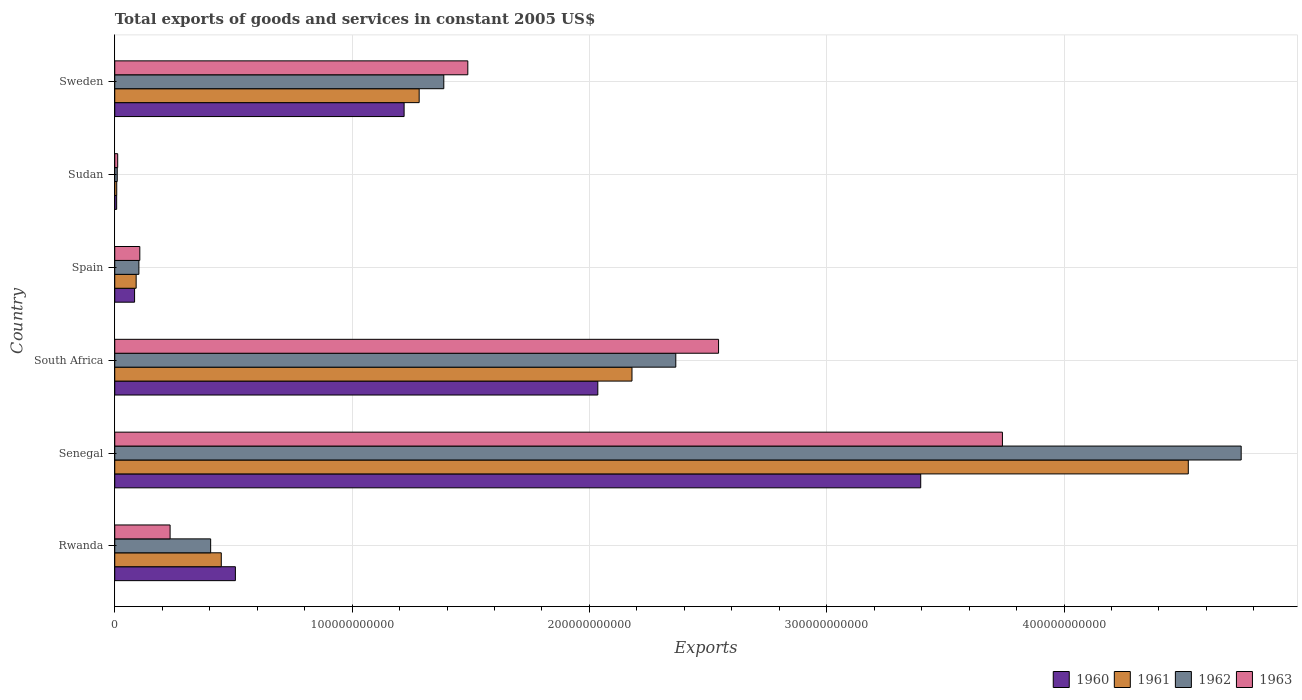How many different coloured bars are there?
Your answer should be very brief. 4. Are the number of bars per tick equal to the number of legend labels?
Your response must be concise. Yes. Are the number of bars on each tick of the Y-axis equal?
Offer a terse response. Yes. What is the label of the 4th group of bars from the top?
Offer a terse response. South Africa. In how many cases, is the number of bars for a given country not equal to the number of legend labels?
Ensure brevity in your answer.  0. What is the total exports of goods and services in 1962 in Spain?
Offer a very short reply. 1.02e+1. Across all countries, what is the maximum total exports of goods and services in 1963?
Your answer should be compact. 3.74e+11. Across all countries, what is the minimum total exports of goods and services in 1960?
Keep it short and to the point. 8.03e+08. In which country was the total exports of goods and services in 1962 maximum?
Your answer should be compact. Senegal. In which country was the total exports of goods and services in 1961 minimum?
Your answer should be compact. Sudan. What is the total total exports of goods and services in 1963 in the graph?
Keep it short and to the point. 8.12e+11. What is the difference between the total exports of goods and services in 1960 in Senegal and that in Spain?
Give a very brief answer. 3.31e+11. What is the difference between the total exports of goods and services in 1963 in Sweden and the total exports of goods and services in 1962 in Spain?
Your response must be concise. 1.39e+11. What is the average total exports of goods and services in 1962 per country?
Keep it short and to the point. 1.50e+11. What is the difference between the total exports of goods and services in 1962 and total exports of goods and services in 1960 in South Africa?
Offer a very short reply. 3.29e+1. What is the ratio of the total exports of goods and services in 1962 in Senegal to that in South Africa?
Provide a succinct answer. 2.01. Is the difference between the total exports of goods and services in 1962 in Rwanda and Sudan greater than the difference between the total exports of goods and services in 1960 in Rwanda and Sudan?
Your answer should be very brief. No. What is the difference between the highest and the second highest total exports of goods and services in 1963?
Offer a very short reply. 1.20e+11. What is the difference between the highest and the lowest total exports of goods and services in 1960?
Keep it short and to the point. 3.39e+11. Is the sum of the total exports of goods and services in 1961 in South Africa and Sweden greater than the maximum total exports of goods and services in 1960 across all countries?
Keep it short and to the point. Yes. What does the 3rd bar from the top in South Africa represents?
Keep it short and to the point. 1961. Is it the case that in every country, the sum of the total exports of goods and services in 1960 and total exports of goods and services in 1962 is greater than the total exports of goods and services in 1963?
Ensure brevity in your answer.  Yes. How many bars are there?
Offer a very short reply. 24. Are all the bars in the graph horizontal?
Offer a very short reply. Yes. How many countries are there in the graph?
Give a very brief answer. 6. What is the difference between two consecutive major ticks on the X-axis?
Give a very brief answer. 1.00e+11. Are the values on the major ticks of X-axis written in scientific E-notation?
Make the answer very short. No. Does the graph contain any zero values?
Offer a terse response. No. How many legend labels are there?
Give a very brief answer. 4. What is the title of the graph?
Keep it short and to the point. Total exports of goods and services in constant 2005 US$. What is the label or title of the X-axis?
Ensure brevity in your answer.  Exports. What is the label or title of the Y-axis?
Provide a short and direct response. Country. What is the Exports of 1960 in Rwanda?
Your answer should be compact. 5.08e+1. What is the Exports in 1961 in Rwanda?
Your response must be concise. 4.49e+1. What is the Exports of 1962 in Rwanda?
Make the answer very short. 4.04e+1. What is the Exports in 1963 in Rwanda?
Your answer should be compact. 2.33e+1. What is the Exports of 1960 in Senegal?
Your answer should be very brief. 3.40e+11. What is the Exports in 1961 in Senegal?
Ensure brevity in your answer.  4.52e+11. What is the Exports of 1962 in Senegal?
Offer a terse response. 4.75e+11. What is the Exports of 1963 in Senegal?
Offer a very short reply. 3.74e+11. What is the Exports of 1960 in South Africa?
Your answer should be very brief. 2.04e+11. What is the Exports in 1961 in South Africa?
Make the answer very short. 2.18e+11. What is the Exports of 1962 in South Africa?
Your response must be concise. 2.36e+11. What is the Exports in 1963 in South Africa?
Your answer should be compact. 2.54e+11. What is the Exports of 1960 in Spain?
Ensure brevity in your answer.  8.35e+09. What is the Exports of 1961 in Spain?
Ensure brevity in your answer.  9.02e+09. What is the Exports in 1962 in Spain?
Provide a short and direct response. 1.02e+1. What is the Exports in 1963 in Spain?
Provide a succinct answer. 1.06e+1. What is the Exports in 1960 in Sudan?
Offer a terse response. 8.03e+08. What is the Exports of 1961 in Sudan?
Offer a terse response. 8.33e+08. What is the Exports in 1962 in Sudan?
Keep it short and to the point. 1.04e+09. What is the Exports of 1963 in Sudan?
Keep it short and to the point. 1.24e+09. What is the Exports in 1960 in Sweden?
Your answer should be very brief. 1.22e+11. What is the Exports in 1961 in Sweden?
Provide a short and direct response. 1.28e+11. What is the Exports of 1962 in Sweden?
Offer a terse response. 1.39e+11. What is the Exports of 1963 in Sweden?
Make the answer very short. 1.49e+11. Across all countries, what is the maximum Exports in 1960?
Offer a very short reply. 3.40e+11. Across all countries, what is the maximum Exports in 1961?
Make the answer very short. 4.52e+11. Across all countries, what is the maximum Exports in 1962?
Make the answer very short. 4.75e+11. Across all countries, what is the maximum Exports of 1963?
Offer a terse response. 3.74e+11. Across all countries, what is the minimum Exports of 1960?
Provide a short and direct response. 8.03e+08. Across all countries, what is the minimum Exports of 1961?
Your answer should be very brief. 8.33e+08. Across all countries, what is the minimum Exports in 1962?
Offer a terse response. 1.04e+09. Across all countries, what is the minimum Exports in 1963?
Your response must be concise. 1.24e+09. What is the total Exports of 1960 in the graph?
Make the answer very short. 7.25e+11. What is the total Exports of 1961 in the graph?
Your response must be concise. 8.53e+11. What is the total Exports in 1962 in the graph?
Provide a short and direct response. 9.01e+11. What is the total Exports in 1963 in the graph?
Give a very brief answer. 8.12e+11. What is the difference between the Exports of 1960 in Rwanda and that in Senegal?
Provide a short and direct response. -2.89e+11. What is the difference between the Exports in 1961 in Rwanda and that in Senegal?
Your answer should be compact. -4.07e+11. What is the difference between the Exports in 1962 in Rwanda and that in Senegal?
Keep it short and to the point. -4.34e+11. What is the difference between the Exports of 1963 in Rwanda and that in Senegal?
Your response must be concise. -3.51e+11. What is the difference between the Exports in 1960 in Rwanda and that in South Africa?
Give a very brief answer. -1.53e+11. What is the difference between the Exports in 1961 in Rwanda and that in South Africa?
Your answer should be compact. -1.73e+11. What is the difference between the Exports in 1962 in Rwanda and that in South Africa?
Offer a terse response. -1.96e+11. What is the difference between the Exports of 1963 in Rwanda and that in South Africa?
Keep it short and to the point. -2.31e+11. What is the difference between the Exports in 1960 in Rwanda and that in Spain?
Your answer should be compact. 4.25e+1. What is the difference between the Exports of 1961 in Rwanda and that in Spain?
Ensure brevity in your answer.  3.59e+1. What is the difference between the Exports of 1962 in Rwanda and that in Spain?
Keep it short and to the point. 3.02e+1. What is the difference between the Exports in 1963 in Rwanda and that in Spain?
Give a very brief answer. 1.28e+1. What is the difference between the Exports in 1960 in Rwanda and that in Sudan?
Provide a short and direct response. 5.00e+1. What is the difference between the Exports in 1961 in Rwanda and that in Sudan?
Provide a short and direct response. 4.41e+1. What is the difference between the Exports of 1962 in Rwanda and that in Sudan?
Your answer should be compact. 3.94e+1. What is the difference between the Exports in 1963 in Rwanda and that in Sudan?
Give a very brief answer. 2.21e+1. What is the difference between the Exports of 1960 in Rwanda and that in Sweden?
Provide a short and direct response. -7.11e+1. What is the difference between the Exports in 1961 in Rwanda and that in Sweden?
Keep it short and to the point. -8.34e+1. What is the difference between the Exports of 1962 in Rwanda and that in Sweden?
Your answer should be very brief. -9.82e+1. What is the difference between the Exports of 1963 in Rwanda and that in Sweden?
Your answer should be very brief. -1.25e+11. What is the difference between the Exports in 1960 in Senegal and that in South Africa?
Your answer should be compact. 1.36e+11. What is the difference between the Exports in 1961 in Senegal and that in South Africa?
Make the answer very short. 2.34e+11. What is the difference between the Exports in 1962 in Senegal and that in South Africa?
Your response must be concise. 2.38e+11. What is the difference between the Exports in 1963 in Senegal and that in South Africa?
Your answer should be compact. 1.20e+11. What is the difference between the Exports in 1960 in Senegal and that in Spain?
Ensure brevity in your answer.  3.31e+11. What is the difference between the Exports of 1961 in Senegal and that in Spain?
Offer a very short reply. 4.43e+11. What is the difference between the Exports of 1962 in Senegal and that in Spain?
Ensure brevity in your answer.  4.64e+11. What is the difference between the Exports in 1963 in Senegal and that in Spain?
Provide a short and direct response. 3.63e+11. What is the difference between the Exports of 1960 in Senegal and that in Sudan?
Give a very brief answer. 3.39e+11. What is the difference between the Exports of 1961 in Senegal and that in Sudan?
Offer a very short reply. 4.52e+11. What is the difference between the Exports in 1962 in Senegal and that in Sudan?
Your answer should be compact. 4.74e+11. What is the difference between the Exports of 1963 in Senegal and that in Sudan?
Offer a terse response. 3.73e+11. What is the difference between the Exports of 1960 in Senegal and that in Sweden?
Provide a short and direct response. 2.18e+11. What is the difference between the Exports in 1961 in Senegal and that in Sweden?
Offer a terse response. 3.24e+11. What is the difference between the Exports in 1962 in Senegal and that in Sweden?
Offer a terse response. 3.36e+11. What is the difference between the Exports of 1963 in Senegal and that in Sweden?
Your answer should be compact. 2.25e+11. What is the difference between the Exports of 1960 in South Africa and that in Spain?
Keep it short and to the point. 1.95e+11. What is the difference between the Exports of 1961 in South Africa and that in Spain?
Your response must be concise. 2.09e+11. What is the difference between the Exports in 1962 in South Africa and that in Spain?
Your answer should be very brief. 2.26e+11. What is the difference between the Exports of 1963 in South Africa and that in Spain?
Make the answer very short. 2.44e+11. What is the difference between the Exports in 1960 in South Africa and that in Sudan?
Your response must be concise. 2.03e+11. What is the difference between the Exports in 1961 in South Africa and that in Sudan?
Provide a short and direct response. 2.17e+11. What is the difference between the Exports of 1962 in South Africa and that in Sudan?
Provide a succinct answer. 2.35e+11. What is the difference between the Exports of 1963 in South Africa and that in Sudan?
Keep it short and to the point. 2.53e+11. What is the difference between the Exports in 1960 in South Africa and that in Sweden?
Your answer should be compact. 8.16e+1. What is the difference between the Exports of 1961 in South Africa and that in Sweden?
Offer a very short reply. 8.97e+1. What is the difference between the Exports of 1962 in South Africa and that in Sweden?
Provide a short and direct response. 9.78e+1. What is the difference between the Exports of 1963 in South Africa and that in Sweden?
Provide a succinct answer. 1.06e+11. What is the difference between the Exports in 1960 in Spain and that in Sudan?
Provide a short and direct response. 7.55e+09. What is the difference between the Exports in 1961 in Spain and that in Sudan?
Give a very brief answer. 8.18e+09. What is the difference between the Exports of 1962 in Spain and that in Sudan?
Give a very brief answer. 9.12e+09. What is the difference between the Exports of 1963 in Spain and that in Sudan?
Ensure brevity in your answer.  9.32e+09. What is the difference between the Exports of 1960 in Spain and that in Sweden?
Your response must be concise. -1.14e+11. What is the difference between the Exports of 1961 in Spain and that in Sweden?
Provide a short and direct response. -1.19e+11. What is the difference between the Exports of 1962 in Spain and that in Sweden?
Offer a terse response. -1.28e+11. What is the difference between the Exports of 1963 in Spain and that in Sweden?
Offer a terse response. -1.38e+11. What is the difference between the Exports in 1960 in Sudan and that in Sweden?
Your answer should be very brief. -1.21e+11. What is the difference between the Exports of 1961 in Sudan and that in Sweden?
Offer a terse response. -1.27e+11. What is the difference between the Exports of 1962 in Sudan and that in Sweden?
Keep it short and to the point. -1.38e+11. What is the difference between the Exports in 1963 in Sudan and that in Sweden?
Your answer should be compact. -1.48e+11. What is the difference between the Exports in 1960 in Rwanda and the Exports in 1961 in Senegal?
Provide a short and direct response. -4.02e+11. What is the difference between the Exports in 1960 in Rwanda and the Exports in 1962 in Senegal?
Provide a short and direct response. -4.24e+11. What is the difference between the Exports in 1960 in Rwanda and the Exports in 1963 in Senegal?
Offer a very short reply. -3.23e+11. What is the difference between the Exports of 1961 in Rwanda and the Exports of 1962 in Senegal?
Provide a succinct answer. -4.30e+11. What is the difference between the Exports of 1961 in Rwanda and the Exports of 1963 in Senegal?
Your response must be concise. -3.29e+11. What is the difference between the Exports in 1962 in Rwanda and the Exports in 1963 in Senegal?
Your answer should be compact. -3.34e+11. What is the difference between the Exports of 1960 in Rwanda and the Exports of 1961 in South Africa?
Provide a short and direct response. -1.67e+11. What is the difference between the Exports of 1960 in Rwanda and the Exports of 1962 in South Africa?
Offer a terse response. -1.86e+11. What is the difference between the Exports of 1960 in Rwanda and the Exports of 1963 in South Africa?
Keep it short and to the point. -2.04e+11. What is the difference between the Exports of 1961 in Rwanda and the Exports of 1962 in South Africa?
Offer a very short reply. -1.92e+11. What is the difference between the Exports of 1961 in Rwanda and the Exports of 1963 in South Africa?
Provide a succinct answer. -2.10e+11. What is the difference between the Exports of 1962 in Rwanda and the Exports of 1963 in South Africa?
Make the answer very short. -2.14e+11. What is the difference between the Exports in 1960 in Rwanda and the Exports in 1961 in Spain?
Keep it short and to the point. 4.18e+1. What is the difference between the Exports of 1960 in Rwanda and the Exports of 1962 in Spain?
Provide a succinct answer. 4.07e+1. What is the difference between the Exports in 1960 in Rwanda and the Exports in 1963 in Spain?
Ensure brevity in your answer.  4.03e+1. What is the difference between the Exports of 1961 in Rwanda and the Exports of 1962 in Spain?
Your answer should be compact. 3.47e+1. What is the difference between the Exports in 1961 in Rwanda and the Exports in 1963 in Spain?
Make the answer very short. 3.43e+1. What is the difference between the Exports of 1962 in Rwanda and the Exports of 1963 in Spain?
Your answer should be compact. 2.99e+1. What is the difference between the Exports in 1960 in Rwanda and the Exports in 1961 in Sudan?
Make the answer very short. 5.00e+1. What is the difference between the Exports in 1960 in Rwanda and the Exports in 1962 in Sudan?
Ensure brevity in your answer.  4.98e+1. What is the difference between the Exports in 1960 in Rwanda and the Exports in 1963 in Sudan?
Keep it short and to the point. 4.96e+1. What is the difference between the Exports in 1961 in Rwanda and the Exports in 1962 in Sudan?
Give a very brief answer. 4.38e+1. What is the difference between the Exports in 1961 in Rwanda and the Exports in 1963 in Sudan?
Make the answer very short. 4.36e+1. What is the difference between the Exports in 1962 in Rwanda and the Exports in 1963 in Sudan?
Provide a succinct answer. 3.92e+1. What is the difference between the Exports in 1960 in Rwanda and the Exports in 1961 in Sweden?
Give a very brief answer. -7.74e+1. What is the difference between the Exports in 1960 in Rwanda and the Exports in 1962 in Sweden?
Provide a succinct answer. -8.78e+1. What is the difference between the Exports in 1960 in Rwanda and the Exports in 1963 in Sweden?
Make the answer very short. -9.79e+1. What is the difference between the Exports in 1961 in Rwanda and the Exports in 1962 in Sweden?
Your answer should be very brief. -9.38e+1. What is the difference between the Exports of 1961 in Rwanda and the Exports of 1963 in Sweden?
Provide a succinct answer. -1.04e+11. What is the difference between the Exports in 1962 in Rwanda and the Exports in 1963 in Sweden?
Provide a short and direct response. -1.08e+11. What is the difference between the Exports in 1960 in Senegal and the Exports in 1961 in South Africa?
Your answer should be very brief. 1.22e+11. What is the difference between the Exports of 1960 in Senegal and the Exports of 1962 in South Africa?
Keep it short and to the point. 1.03e+11. What is the difference between the Exports of 1960 in Senegal and the Exports of 1963 in South Africa?
Provide a succinct answer. 8.52e+1. What is the difference between the Exports of 1961 in Senegal and the Exports of 1962 in South Africa?
Provide a short and direct response. 2.16e+11. What is the difference between the Exports of 1961 in Senegal and the Exports of 1963 in South Africa?
Give a very brief answer. 1.98e+11. What is the difference between the Exports of 1962 in Senegal and the Exports of 1963 in South Africa?
Your response must be concise. 2.20e+11. What is the difference between the Exports in 1960 in Senegal and the Exports in 1961 in Spain?
Your response must be concise. 3.31e+11. What is the difference between the Exports of 1960 in Senegal and the Exports of 1962 in Spain?
Give a very brief answer. 3.29e+11. What is the difference between the Exports of 1960 in Senegal and the Exports of 1963 in Spain?
Keep it short and to the point. 3.29e+11. What is the difference between the Exports in 1961 in Senegal and the Exports in 1962 in Spain?
Make the answer very short. 4.42e+11. What is the difference between the Exports in 1961 in Senegal and the Exports in 1963 in Spain?
Your answer should be very brief. 4.42e+11. What is the difference between the Exports of 1962 in Senegal and the Exports of 1963 in Spain?
Give a very brief answer. 4.64e+11. What is the difference between the Exports of 1960 in Senegal and the Exports of 1961 in Sudan?
Give a very brief answer. 3.39e+11. What is the difference between the Exports of 1960 in Senegal and the Exports of 1962 in Sudan?
Provide a succinct answer. 3.39e+11. What is the difference between the Exports of 1960 in Senegal and the Exports of 1963 in Sudan?
Make the answer very short. 3.38e+11. What is the difference between the Exports of 1961 in Senegal and the Exports of 1962 in Sudan?
Give a very brief answer. 4.51e+11. What is the difference between the Exports of 1961 in Senegal and the Exports of 1963 in Sudan?
Your answer should be very brief. 4.51e+11. What is the difference between the Exports of 1962 in Senegal and the Exports of 1963 in Sudan?
Offer a very short reply. 4.73e+11. What is the difference between the Exports of 1960 in Senegal and the Exports of 1961 in Sweden?
Offer a very short reply. 2.11e+11. What is the difference between the Exports of 1960 in Senegal and the Exports of 1962 in Sweden?
Ensure brevity in your answer.  2.01e+11. What is the difference between the Exports of 1960 in Senegal and the Exports of 1963 in Sweden?
Provide a short and direct response. 1.91e+11. What is the difference between the Exports of 1961 in Senegal and the Exports of 1962 in Sweden?
Keep it short and to the point. 3.14e+11. What is the difference between the Exports in 1961 in Senegal and the Exports in 1963 in Sweden?
Ensure brevity in your answer.  3.04e+11. What is the difference between the Exports in 1962 in Senegal and the Exports in 1963 in Sweden?
Ensure brevity in your answer.  3.26e+11. What is the difference between the Exports in 1960 in South Africa and the Exports in 1961 in Spain?
Provide a succinct answer. 1.95e+11. What is the difference between the Exports in 1960 in South Africa and the Exports in 1962 in Spain?
Your answer should be very brief. 1.93e+11. What is the difference between the Exports in 1960 in South Africa and the Exports in 1963 in Spain?
Provide a succinct answer. 1.93e+11. What is the difference between the Exports in 1961 in South Africa and the Exports in 1962 in Spain?
Provide a succinct answer. 2.08e+11. What is the difference between the Exports in 1961 in South Africa and the Exports in 1963 in Spain?
Offer a very short reply. 2.07e+11. What is the difference between the Exports of 1962 in South Africa and the Exports of 1963 in Spain?
Offer a very short reply. 2.26e+11. What is the difference between the Exports in 1960 in South Africa and the Exports in 1961 in Sudan?
Keep it short and to the point. 2.03e+11. What is the difference between the Exports of 1960 in South Africa and the Exports of 1962 in Sudan?
Your answer should be very brief. 2.03e+11. What is the difference between the Exports in 1960 in South Africa and the Exports in 1963 in Sudan?
Give a very brief answer. 2.02e+11. What is the difference between the Exports in 1961 in South Africa and the Exports in 1962 in Sudan?
Provide a short and direct response. 2.17e+11. What is the difference between the Exports in 1961 in South Africa and the Exports in 1963 in Sudan?
Provide a short and direct response. 2.17e+11. What is the difference between the Exports in 1962 in South Africa and the Exports in 1963 in Sudan?
Your answer should be very brief. 2.35e+11. What is the difference between the Exports in 1960 in South Africa and the Exports in 1961 in Sweden?
Your answer should be very brief. 7.53e+1. What is the difference between the Exports in 1960 in South Africa and the Exports in 1962 in Sweden?
Your response must be concise. 6.49e+1. What is the difference between the Exports of 1960 in South Africa and the Exports of 1963 in Sweden?
Your response must be concise. 5.48e+1. What is the difference between the Exports in 1961 in South Africa and the Exports in 1962 in Sweden?
Offer a terse response. 7.93e+1. What is the difference between the Exports of 1961 in South Africa and the Exports of 1963 in Sweden?
Give a very brief answer. 6.92e+1. What is the difference between the Exports in 1962 in South Africa and the Exports in 1963 in Sweden?
Keep it short and to the point. 8.76e+1. What is the difference between the Exports of 1960 in Spain and the Exports of 1961 in Sudan?
Offer a very short reply. 7.52e+09. What is the difference between the Exports in 1960 in Spain and the Exports in 1962 in Sudan?
Offer a terse response. 7.31e+09. What is the difference between the Exports of 1960 in Spain and the Exports of 1963 in Sudan?
Keep it short and to the point. 7.11e+09. What is the difference between the Exports of 1961 in Spain and the Exports of 1962 in Sudan?
Give a very brief answer. 7.97e+09. What is the difference between the Exports in 1961 in Spain and the Exports in 1963 in Sudan?
Provide a short and direct response. 7.78e+09. What is the difference between the Exports in 1962 in Spain and the Exports in 1963 in Sudan?
Your answer should be very brief. 8.93e+09. What is the difference between the Exports in 1960 in Spain and the Exports in 1961 in Sweden?
Offer a very short reply. -1.20e+11. What is the difference between the Exports of 1960 in Spain and the Exports of 1962 in Sweden?
Your answer should be compact. -1.30e+11. What is the difference between the Exports of 1960 in Spain and the Exports of 1963 in Sweden?
Offer a terse response. -1.40e+11. What is the difference between the Exports in 1961 in Spain and the Exports in 1962 in Sweden?
Offer a very short reply. -1.30e+11. What is the difference between the Exports in 1961 in Spain and the Exports in 1963 in Sweden?
Give a very brief answer. -1.40e+11. What is the difference between the Exports in 1962 in Spain and the Exports in 1963 in Sweden?
Your answer should be very brief. -1.39e+11. What is the difference between the Exports in 1960 in Sudan and the Exports in 1961 in Sweden?
Your response must be concise. -1.27e+11. What is the difference between the Exports in 1960 in Sudan and the Exports in 1962 in Sweden?
Your answer should be compact. -1.38e+11. What is the difference between the Exports in 1960 in Sudan and the Exports in 1963 in Sweden?
Your answer should be very brief. -1.48e+11. What is the difference between the Exports of 1961 in Sudan and the Exports of 1962 in Sweden?
Offer a terse response. -1.38e+11. What is the difference between the Exports of 1961 in Sudan and the Exports of 1963 in Sweden?
Your response must be concise. -1.48e+11. What is the difference between the Exports of 1962 in Sudan and the Exports of 1963 in Sweden?
Keep it short and to the point. -1.48e+11. What is the average Exports of 1960 per country?
Your answer should be very brief. 1.21e+11. What is the average Exports in 1961 per country?
Keep it short and to the point. 1.42e+11. What is the average Exports in 1962 per country?
Provide a short and direct response. 1.50e+11. What is the average Exports of 1963 per country?
Give a very brief answer. 1.35e+11. What is the difference between the Exports in 1960 and Exports in 1961 in Rwanda?
Ensure brevity in your answer.  5.95e+09. What is the difference between the Exports in 1960 and Exports in 1962 in Rwanda?
Your response must be concise. 1.04e+1. What is the difference between the Exports in 1960 and Exports in 1963 in Rwanda?
Offer a very short reply. 2.75e+1. What is the difference between the Exports in 1961 and Exports in 1962 in Rwanda?
Ensure brevity in your answer.  4.47e+09. What is the difference between the Exports in 1961 and Exports in 1963 in Rwanda?
Give a very brief answer. 2.16e+1. What is the difference between the Exports of 1962 and Exports of 1963 in Rwanda?
Provide a short and direct response. 1.71e+1. What is the difference between the Exports in 1960 and Exports in 1961 in Senegal?
Your answer should be compact. -1.13e+11. What is the difference between the Exports of 1960 and Exports of 1962 in Senegal?
Offer a very short reply. -1.35e+11. What is the difference between the Exports in 1960 and Exports in 1963 in Senegal?
Offer a terse response. -3.44e+1. What is the difference between the Exports in 1961 and Exports in 1962 in Senegal?
Ensure brevity in your answer.  -2.23e+1. What is the difference between the Exports of 1961 and Exports of 1963 in Senegal?
Provide a short and direct response. 7.83e+1. What is the difference between the Exports of 1962 and Exports of 1963 in Senegal?
Offer a very short reply. 1.01e+11. What is the difference between the Exports of 1960 and Exports of 1961 in South Africa?
Your answer should be very brief. -1.44e+1. What is the difference between the Exports of 1960 and Exports of 1962 in South Africa?
Your answer should be very brief. -3.29e+1. What is the difference between the Exports in 1960 and Exports in 1963 in South Africa?
Your response must be concise. -5.09e+1. What is the difference between the Exports in 1961 and Exports in 1962 in South Africa?
Your answer should be compact. -1.85e+1. What is the difference between the Exports in 1961 and Exports in 1963 in South Africa?
Give a very brief answer. -3.65e+1. What is the difference between the Exports in 1962 and Exports in 1963 in South Africa?
Provide a succinct answer. -1.80e+1. What is the difference between the Exports of 1960 and Exports of 1961 in Spain?
Offer a very short reply. -6.64e+08. What is the difference between the Exports in 1960 and Exports in 1962 in Spain?
Your answer should be compact. -1.82e+09. What is the difference between the Exports in 1960 and Exports in 1963 in Spain?
Your answer should be compact. -2.21e+09. What is the difference between the Exports of 1961 and Exports of 1962 in Spain?
Make the answer very short. -1.15e+09. What is the difference between the Exports of 1961 and Exports of 1963 in Spain?
Give a very brief answer. -1.54e+09. What is the difference between the Exports in 1962 and Exports in 1963 in Spain?
Provide a short and direct response. -3.90e+08. What is the difference between the Exports of 1960 and Exports of 1961 in Sudan?
Your answer should be compact. -3.01e+07. What is the difference between the Exports in 1960 and Exports in 1962 in Sudan?
Provide a succinct answer. -2.41e+08. What is the difference between the Exports in 1960 and Exports in 1963 in Sudan?
Provide a short and direct response. -4.34e+08. What is the difference between the Exports of 1961 and Exports of 1962 in Sudan?
Give a very brief answer. -2.11e+08. What is the difference between the Exports of 1961 and Exports of 1963 in Sudan?
Keep it short and to the point. -4.04e+08. What is the difference between the Exports of 1962 and Exports of 1963 in Sudan?
Keep it short and to the point. -1.93e+08. What is the difference between the Exports in 1960 and Exports in 1961 in Sweden?
Offer a terse response. -6.34e+09. What is the difference between the Exports in 1960 and Exports in 1962 in Sweden?
Make the answer very short. -1.67e+1. What is the difference between the Exports of 1960 and Exports of 1963 in Sweden?
Offer a very short reply. -2.68e+1. What is the difference between the Exports of 1961 and Exports of 1962 in Sweden?
Offer a very short reply. -1.04e+1. What is the difference between the Exports in 1961 and Exports in 1963 in Sweden?
Your response must be concise. -2.05e+1. What is the difference between the Exports of 1962 and Exports of 1963 in Sweden?
Offer a very short reply. -1.01e+1. What is the ratio of the Exports of 1960 in Rwanda to that in Senegal?
Give a very brief answer. 0.15. What is the ratio of the Exports in 1961 in Rwanda to that in Senegal?
Your response must be concise. 0.1. What is the ratio of the Exports in 1962 in Rwanda to that in Senegal?
Ensure brevity in your answer.  0.09. What is the ratio of the Exports of 1963 in Rwanda to that in Senegal?
Your answer should be compact. 0.06. What is the ratio of the Exports in 1960 in Rwanda to that in South Africa?
Ensure brevity in your answer.  0.25. What is the ratio of the Exports in 1961 in Rwanda to that in South Africa?
Keep it short and to the point. 0.21. What is the ratio of the Exports in 1962 in Rwanda to that in South Africa?
Provide a short and direct response. 0.17. What is the ratio of the Exports of 1963 in Rwanda to that in South Africa?
Your answer should be compact. 0.09. What is the ratio of the Exports in 1960 in Rwanda to that in Spain?
Give a very brief answer. 6.09. What is the ratio of the Exports of 1961 in Rwanda to that in Spain?
Make the answer very short. 4.98. What is the ratio of the Exports in 1962 in Rwanda to that in Spain?
Offer a terse response. 3.98. What is the ratio of the Exports in 1963 in Rwanda to that in Spain?
Ensure brevity in your answer.  2.21. What is the ratio of the Exports in 1960 in Rwanda to that in Sudan?
Offer a very short reply. 63.33. What is the ratio of the Exports of 1961 in Rwanda to that in Sudan?
Your answer should be compact. 53.9. What is the ratio of the Exports in 1962 in Rwanda to that in Sudan?
Ensure brevity in your answer.  38.72. What is the ratio of the Exports of 1963 in Rwanda to that in Sudan?
Provide a short and direct response. 18.85. What is the ratio of the Exports of 1960 in Rwanda to that in Sweden?
Make the answer very short. 0.42. What is the ratio of the Exports in 1961 in Rwanda to that in Sweden?
Ensure brevity in your answer.  0.35. What is the ratio of the Exports in 1962 in Rwanda to that in Sweden?
Your answer should be very brief. 0.29. What is the ratio of the Exports of 1963 in Rwanda to that in Sweden?
Your response must be concise. 0.16. What is the ratio of the Exports in 1960 in Senegal to that in South Africa?
Make the answer very short. 1.67. What is the ratio of the Exports of 1961 in Senegal to that in South Africa?
Your answer should be very brief. 2.08. What is the ratio of the Exports in 1962 in Senegal to that in South Africa?
Ensure brevity in your answer.  2.01. What is the ratio of the Exports in 1963 in Senegal to that in South Africa?
Your answer should be compact. 1.47. What is the ratio of the Exports of 1960 in Senegal to that in Spain?
Provide a short and direct response. 40.66. What is the ratio of the Exports of 1961 in Senegal to that in Spain?
Give a very brief answer. 50.17. What is the ratio of the Exports of 1962 in Senegal to that in Spain?
Ensure brevity in your answer.  46.69. What is the ratio of the Exports in 1963 in Senegal to that in Spain?
Your answer should be compact. 35.43. What is the ratio of the Exports in 1960 in Senegal to that in Sudan?
Give a very brief answer. 423.14. What is the ratio of the Exports of 1961 in Senegal to that in Sudan?
Provide a short and direct response. 543.23. What is the ratio of the Exports of 1962 in Senegal to that in Sudan?
Give a very brief answer. 454.79. What is the ratio of the Exports of 1963 in Senegal to that in Sudan?
Make the answer very short. 302.44. What is the ratio of the Exports of 1960 in Senegal to that in Sweden?
Give a very brief answer. 2.79. What is the ratio of the Exports in 1961 in Senegal to that in Sweden?
Give a very brief answer. 3.53. What is the ratio of the Exports in 1962 in Senegal to that in Sweden?
Provide a succinct answer. 3.42. What is the ratio of the Exports of 1963 in Senegal to that in Sweden?
Provide a short and direct response. 2.51. What is the ratio of the Exports in 1960 in South Africa to that in Spain?
Ensure brevity in your answer.  24.37. What is the ratio of the Exports in 1961 in South Africa to that in Spain?
Give a very brief answer. 24.17. What is the ratio of the Exports in 1962 in South Africa to that in Spain?
Offer a terse response. 23.25. What is the ratio of the Exports of 1963 in South Africa to that in Spain?
Provide a short and direct response. 24.1. What is the ratio of the Exports of 1960 in South Africa to that in Sudan?
Give a very brief answer. 253.61. What is the ratio of the Exports in 1961 in South Africa to that in Sudan?
Your response must be concise. 261.73. What is the ratio of the Exports of 1962 in South Africa to that in Sudan?
Give a very brief answer. 226.52. What is the ratio of the Exports in 1963 in South Africa to that in Sudan?
Keep it short and to the point. 205.72. What is the ratio of the Exports of 1960 in South Africa to that in Sweden?
Your response must be concise. 1.67. What is the ratio of the Exports of 1961 in South Africa to that in Sweden?
Offer a terse response. 1.7. What is the ratio of the Exports in 1962 in South Africa to that in Sweden?
Your response must be concise. 1.71. What is the ratio of the Exports of 1963 in South Africa to that in Sweden?
Offer a very short reply. 1.71. What is the ratio of the Exports in 1960 in Spain to that in Sudan?
Your answer should be compact. 10.41. What is the ratio of the Exports in 1961 in Spain to that in Sudan?
Offer a terse response. 10.83. What is the ratio of the Exports of 1962 in Spain to that in Sudan?
Offer a very short reply. 9.74. What is the ratio of the Exports of 1963 in Spain to that in Sudan?
Ensure brevity in your answer.  8.54. What is the ratio of the Exports of 1960 in Spain to that in Sweden?
Provide a short and direct response. 0.07. What is the ratio of the Exports of 1961 in Spain to that in Sweden?
Give a very brief answer. 0.07. What is the ratio of the Exports in 1962 in Spain to that in Sweden?
Give a very brief answer. 0.07. What is the ratio of the Exports of 1963 in Spain to that in Sweden?
Provide a short and direct response. 0.07. What is the ratio of the Exports of 1960 in Sudan to that in Sweden?
Offer a terse response. 0.01. What is the ratio of the Exports in 1961 in Sudan to that in Sweden?
Your response must be concise. 0.01. What is the ratio of the Exports of 1962 in Sudan to that in Sweden?
Make the answer very short. 0.01. What is the ratio of the Exports of 1963 in Sudan to that in Sweden?
Make the answer very short. 0.01. What is the difference between the highest and the second highest Exports in 1960?
Provide a short and direct response. 1.36e+11. What is the difference between the highest and the second highest Exports in 1961?
Make the answer very short. 2.34e+11. What is the difference between the highest and the second highest Exports of 1962?
Provide a succinct answer. 2.38e+11. What is the difference between the highest and the second highest Exports in 1963?
Offer a very short reply. 1.20e+11. What is the difference between the highest and the lowest Exports in 1960?
Make the answer very short. 3.39e+11. What is the difference between the highest and the lowest Exports in 1961?
Give a very brief answer. 4.52e+11. What is the difference between the highest and the lowest Exports in 1962?
Keep it short and to the point. 4.74e+11. What is the difference between the highest and the lowest Exports in 1963?
Keep it short and to the point. 3.73e+11. 